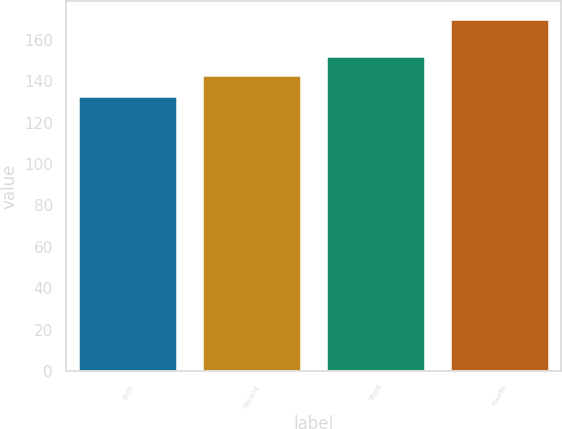<chart> <loc_0><loc_0><loc_500><loc_500><bar_chart><fcel>First<fcel>Second<fcel>Third<fcel>Fourth<nl><fcel>132.87<fcel>143.05<fcel>152.3<fcel>170.03<nl></chart> 